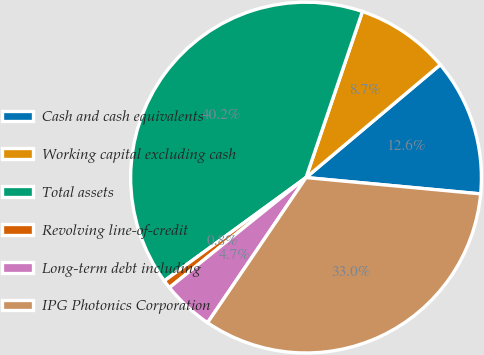<chart> <loc_0><loc_0><loc_500><loc_500><pie_chart><fcel>Cash and cash equivalents<fcel>Working capital excluding cash<fcel>Total assets<fcel>Revolving line-of-credit<fcel>Long-term debt including<fcel>IPG Photonics Corporation<nl><fcel>12.61%<fcel>8.66%<fcel>40.23%<fcel>0.77%<fcel>4.72%<fcel>33.0%<nl></chart> 